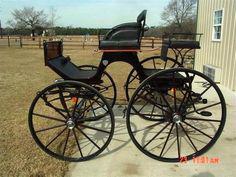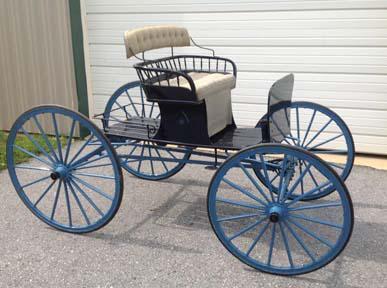The first image is the image on the left, the second image is the image on the right. Evaluate the accuracy of this statement regarding the images: "Left image features a four-wheeled black cart.". Is it true? Answer yes or no. Yes. The first image is the image on the left, the second image is the image on the right. Examine the images to the left and right. Is the description "The carriage on the right most image has yellow wheels." accurate? Answer yes or no. No. 